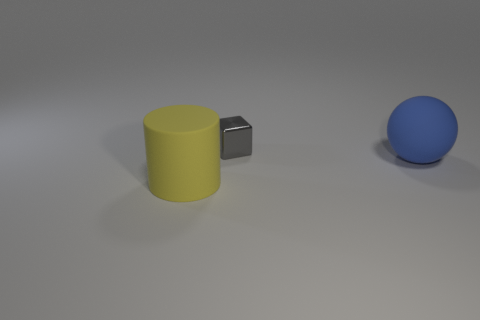What number of other things are the same material as the blue thing?
Make the answer very short. 1. Does the big matte object on the left side of the metal block have the same shape as the rubber thing that is right of the gray object?
Provide a short and direct response. No. Is the material of the tiny gray block the same as the ball?
Provide a succinct answer. No. How big is the object behind the matte object on the right side of the large thing that is left of the tiny block?
Keep it short and to the point. Small. What number of other objects are there of the same color as the big rubber cylinder?
Offer a terse response. 0. What shape is the blue thing that is the same size as the yellow cylinder?
Your answer should be very brief. Sphere. How many big objects are cylinders or blue objects?
Make the answer very short. 2. Are there any big matte balls that are to the left of the shiny object to the left of the matte thing that is right of the small gray shiny object?
Provide a succinct answer. No. Are there any gray metallic objects that have the same size as the shiny cube?
Ensure brevity in your answer.  No. What is the material of the yellow object that is the same size as the blue object?
Make the answer very short. Rubber. 